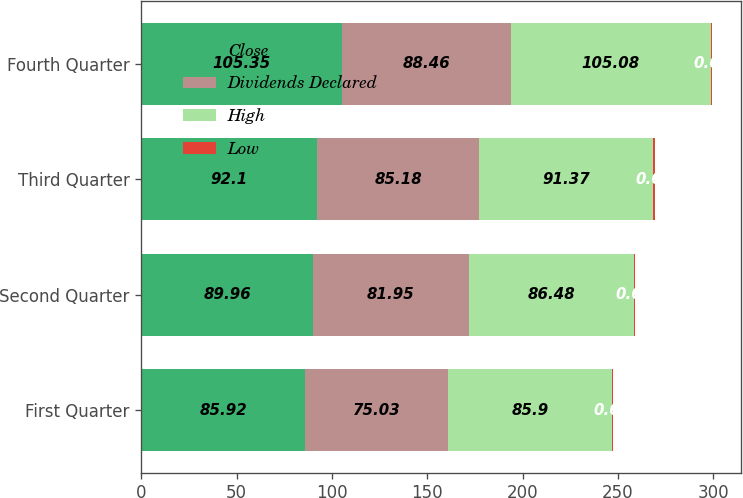<chart> <loc_0><loc_0><loc_500><loc_500><stacked_bar_chart><ecel><fcel>First Quarter<fcel>Second Quarter<fcel>Third Quarter<fcel>Fourth Quarter<nl><fcel>Close<fcel>85.92<fcel>89.96<fcel>92.1<fcel>105.35<nl><fcel>Dividends Declared<fcel>75.03<fcel>81.95<fcel>85.18<fcel>88.46<nl><fcel>High<fcel>85.9<fcel>86.48<fcel>91.37<fcel>105.08<nl><fcel>Low<fcel>0.62<fcel>0.62<fcel>0.62<fcel>0.62<nl></chart> 